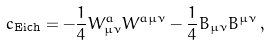Convert formula to latex. <formula><loc_0><loc_0><loc_500><loc_500>\L c _ { \text {Eich} } = - \frac { 1 } { 4 } W ^ { a } _ { \mu \nu } W ^ { a \mu \nu } - \frac { 1 } { 4 } B _ { \mu \nu } B ^ { \mu \nu } \, ,</formula> 